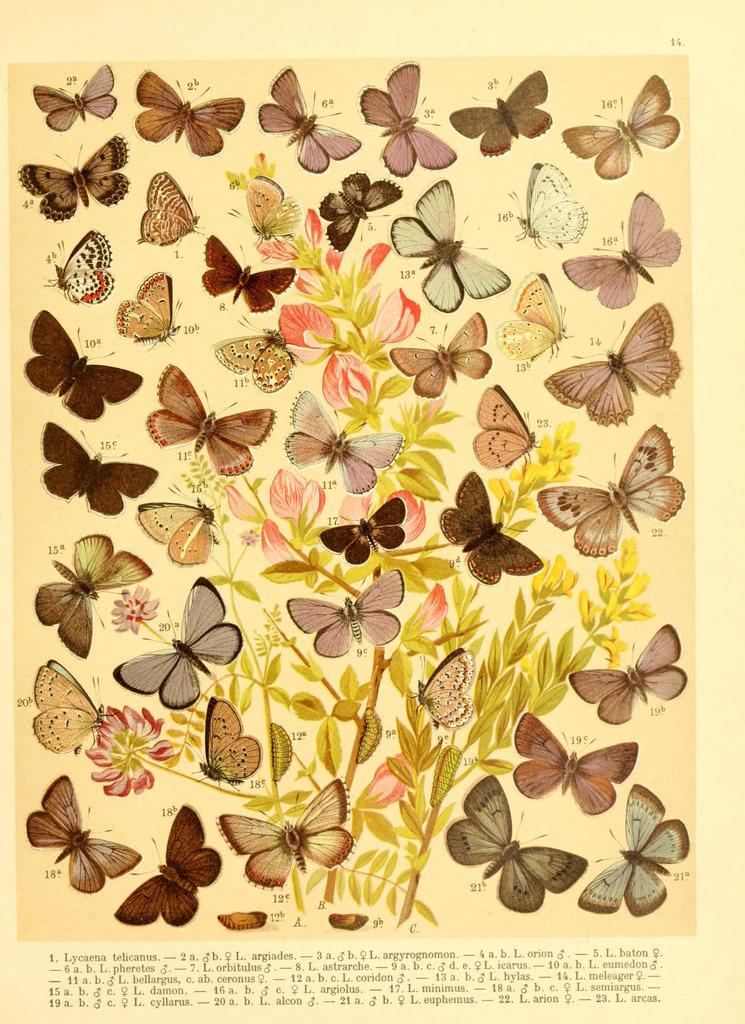What is depicted on the paper in the image? The paper contains a drawing of a plant. Are there any additional elements in the drawing on the paper? Yes, the drawing on the paper includes butterflies. What type of songs can be heard coming from the plant in the drawing? There are no songs present in the image, as it features a drawing of a plant with butterflies. 